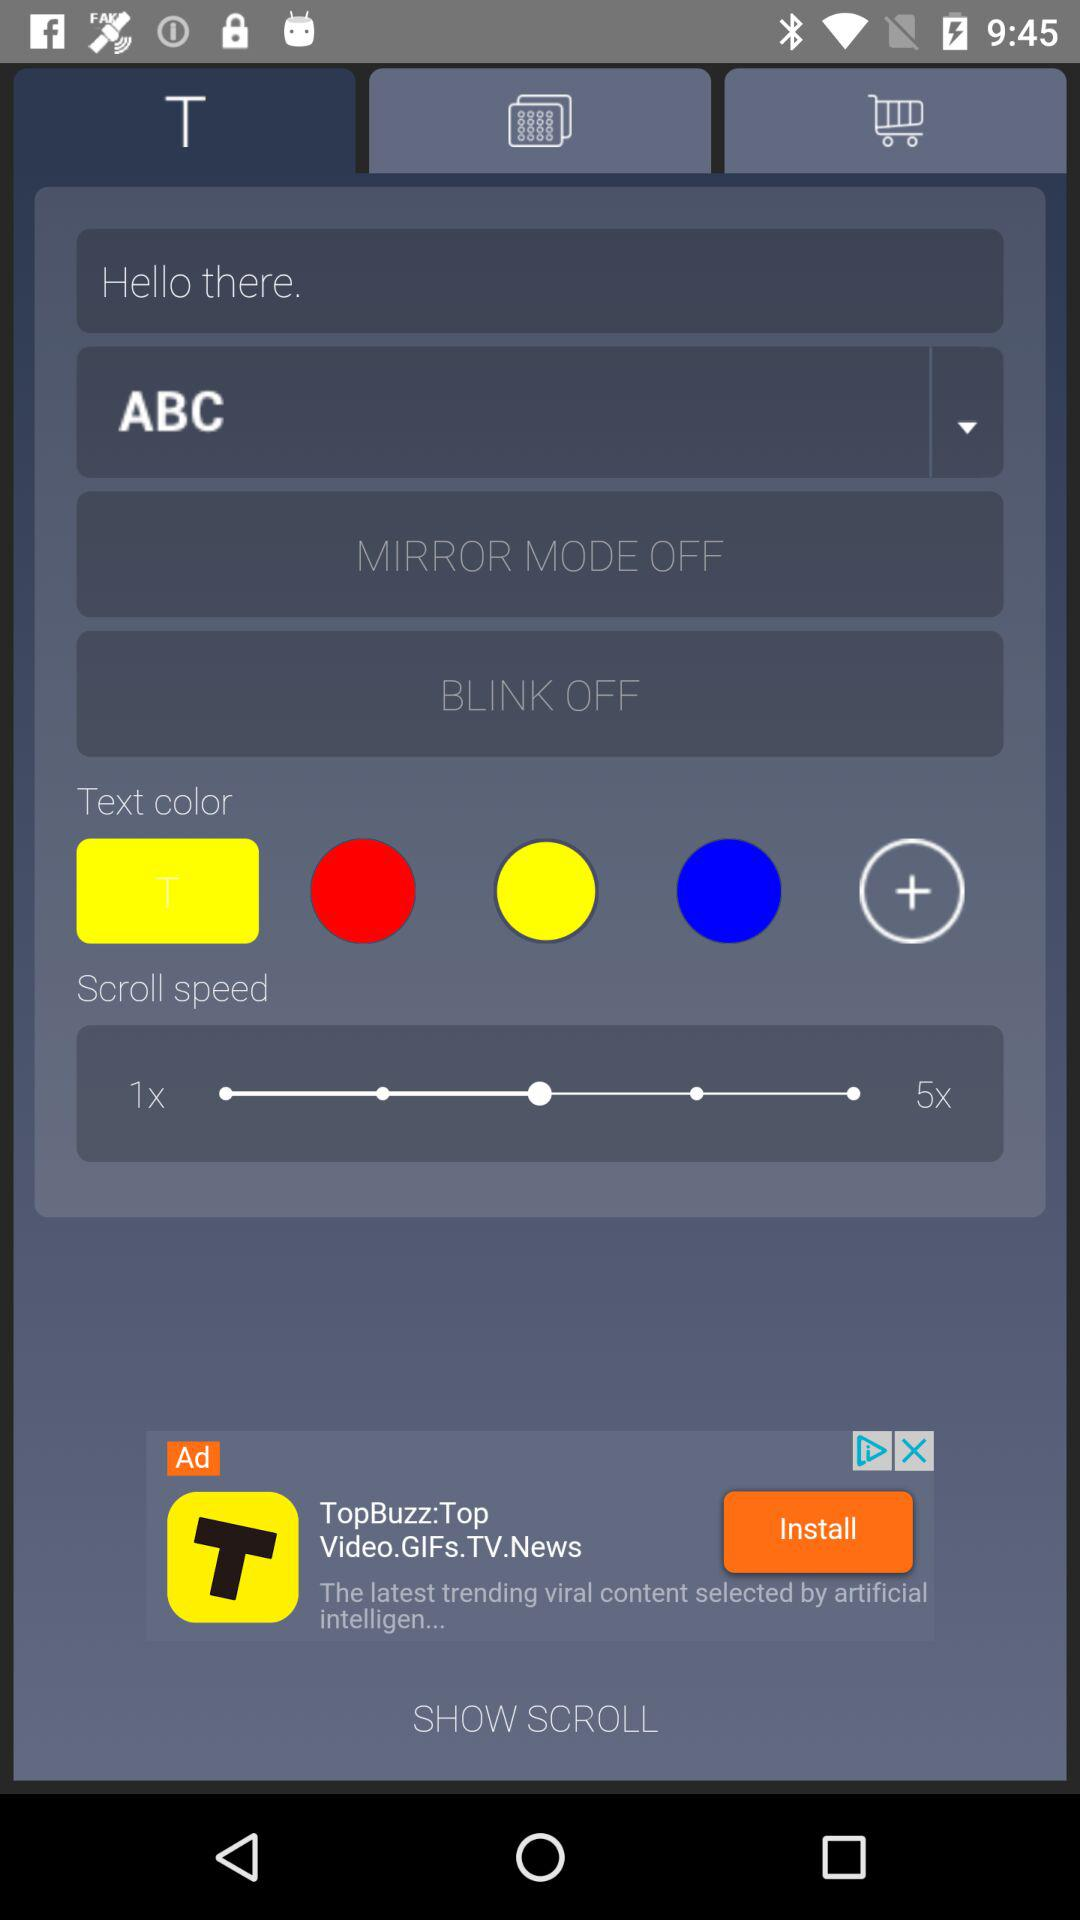Which tab is selected? The selected tab is "T". 